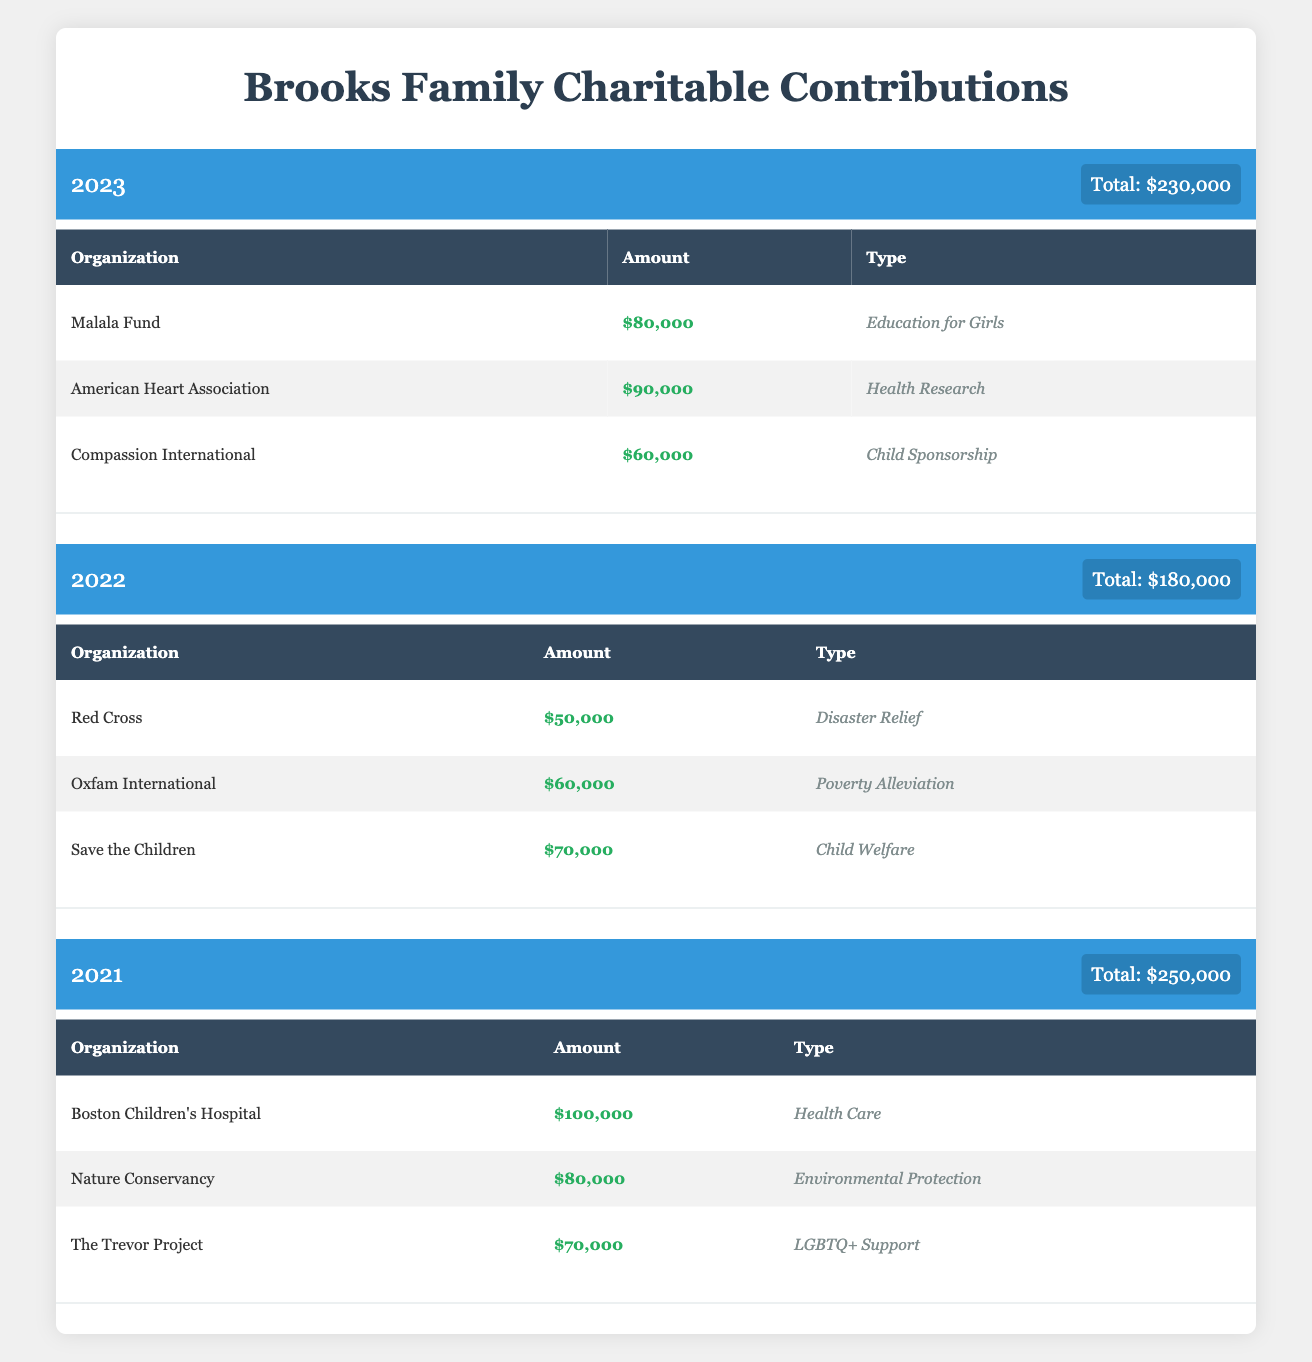What was the total charitable contribution made by the Brooks family in 2018? The total contribution for the year 2018 is explicitly stated in the table as $140,000.
Answer: $140,000 How much did the Brooks family contribute to the American Red Cross in 2013? In the year 2013, the Brooks family donated $50,000 to the American Red Cross, which is mentioned under that year’s contributions.
Answer: $50,000 What is the average total contribution made by the Brooks family from 2013 to 2023? To calculate the average, first sum the total contributions from each year: (150,000 + 120,000 + 175,000 + 200,000 + 160,000 + 140,000 + 220,000 + 300,000 + 250,000 + 180,000 + 230,000) = 1,899,000. There are 11 years, so the average is 1,899,000 / 11 = 172,636.36.
Answer: $172,636.36 Did the Brooks family contribute to any organization focused on child welfare in 2021? Yes, they contributed $100,000 to Boston Children's Hospital, which is categorized under Health Care but focuses on child welfare. Therefore, the answer is affirmative.
Answer: Yes Which organization received the highest amount of contribution from the Brooks family in 2020, and how much did they receive? In 2020, Feeding America received the highest contribution of $150,000, which is listed first in that year's organizations.
Answer: Feeding America, $150,000 How much total funding was allocated to environmental organizations in 2019? The contributions to environmental organizations in 2019 include World Wildlife Fund ($100,000) and Direct Relief ($80,000), totaling $180,000. Summing these amounts gives us $100,000 + $80,000 = $180,000 for environmental contributions.
Answer: $180,000 What was the total contribution amount for the year with the largest donation? The year with the largest donation is 2020, with total contributions of $300,000, which is clearly defined in the respective section of the table.
Answer: $300,000 In which two years did the Brooks family contribute to Oxfam International, and what were the amounts? The Brooks family contributed to Oxfam International in 2013 ($30,000) and 2022 ($60,000). Both entries can be identified under their respective years in the table.
Answer: 2013, $30,000; 2022, $60,000 What is the percentage increase in total contributions from 2019 to 2020? First, calculate the difference in total contributions: 2020 ($300,000) - 2019 ($220,000) = $80,000. Next, divide the difference by the 2019 total: $80,000 / $220,000 = 0.3636, then multiply by 100 for the percentage, which is approximately 36.36%.
Answer: 36.36% 